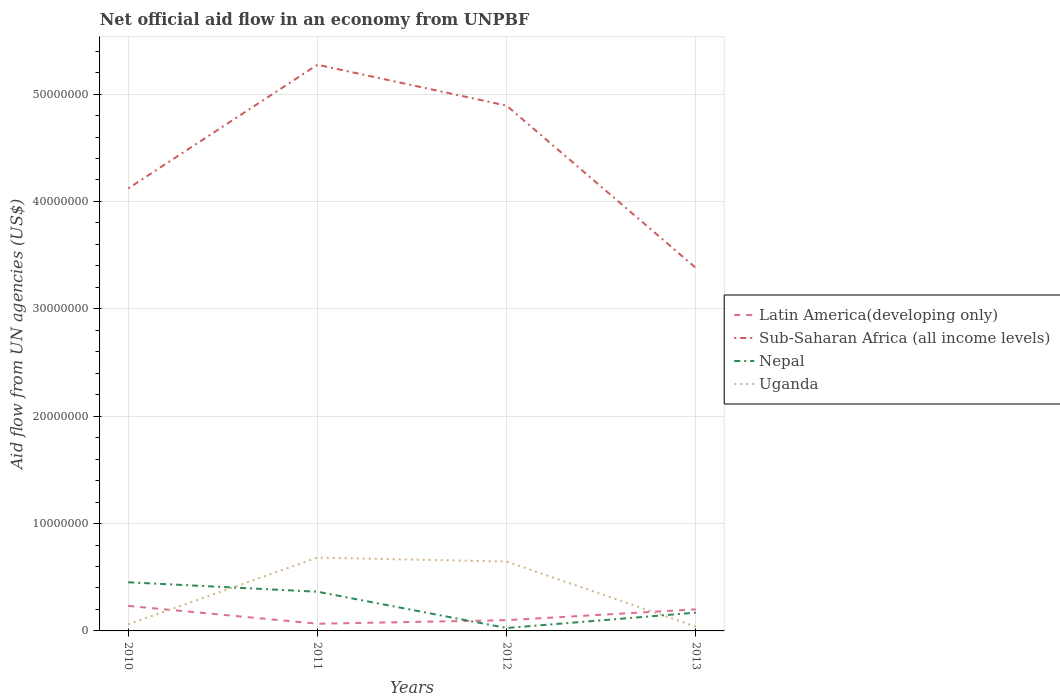How many different coloured lines are there?
Provide a short and direct response. 4. Does the line corresponding to Sub-Saharan Africa (all income levels) intersect with the line corresponding to Latin America(developing only)?
Ensure brevity in your answer.  No. Is the number of lines equal to the number of legend labels?
Offer a terse response. Yes. Across all years, what is the maximum net official aid flow in Nepal?
Make the answer very short. 2.70e+05. What is the total net official aid flow in Sub-Saharan Africa (all income levels) in the graph?
Your response must be concise. 3.81e+06. What is the difference between the highest and the second highest net official aid flow in Latin America(developing only)?
Your answer should be compact. 1.66e+06. Is the net official aid flow in Sub-Saharan Africa (all income levels) strictly greater than the net official aid flow in Latin America(developing only) over the years?
Offer a very short reply. No. How many years are there in the graph?
Ensure brevity in your answer.  4. How are the legend labels stacked?
Provide a short and direct response. Vertical. What is the title of the graph?
Provide a succinct answer. Net official aid flow in an economy from UNPBF. What is the label or title of the Y-axis?
Ensure brevity in your answer.  Aid flow from UN agencies (US$). What is the Aid flow from UN agencies (US$) in Latin America(developing only) in 2010?
Offer a very short reply. 2.33e+06. What is the Aid flow from UN agencies (US$) in Sub-Saharan Africa (all income levels) in 2010?
Offer a terse response. 4.12e+07. What is the Aid flow from UN agencies (US$) in Nepal in 2010?
Your response must be concise. 4.53e+06. What is the Aid flow from UN agencies (US$) of Latin America(developing only) in 2011?
Your answer should be compact. 6.70e+05. What is the Aid flow from UN agencies (US$) in Sub-Saharan Africa (all income levels) in 2011?
Keep it short and to the point. 5.27e+07. What is the Aid flow from UN agencies (US$) of Nepal in 2011?
Offer a terse response. 3.65e+06. What is the Aid flow from UN agencies (US$) of Uganda in 2011?
Keep it short and to the point. 6.83e+06. What is the Aid flow from UN agencies (US$) in Sub-Saharan Africa (all income levels) in 2012?
Your answer should be very brief. 4.89e+07. What is the Aid flow from UN agencies (US$) in Uganda in 2012?
Offer a very short reply. 6.46e+06. What is the Aid flow from UN agencies (US$) of Latin America(developing only) in 2013?
Your answer should be compact. 2.01e+06. What is the Aid flow from UN agencies (US$) of Sub-Saharan Africa (all income levels) in 2013?
Your answer should be compact. 3.38e+07. What is the Aid flow from UN agencies (US$) in Nepal in 2013?
Ensure brevity in your answer.  1.70e+06. Across all years, what is the maximum Aid flow from UN agencies (US$) of Latin America(developing only)?
Offer a very short reply. 2.33e+06. Across all years, what is the maximum Aid flow from UN agencies (US$) of Sub-Saharan Africa (all income levels)?
Provide a short and direct response. 5.27e+07. Across all years, what is the maximum Aid flow from UN agencies (US$) in Nepal?
Ensure brevity in your answer.  4.53e+06. Across all years, what is the maximum Aid flow from UN agencies (US$) of Uganda?
Give a very brief answer. 6.83e+06. Across all years, what is the minimum Aid flow from UN agencies (US$) in Latin America(developing only)?
Offer a terse response. 6.70e+05. Across all years, what is the minimum Aid flow from UN agencies (US$) in Sub-Saharan Africa (all income levels)?
Offer a terse response. 3.38e+07. What is the total Aid flow from UN agencies (US$) in Latin America(developing only) in the graph?
Your answer should be very brief. 6.01e+06. What is the total Aid flow from UN agencies (US$) in Sub-Saharan Africa (all income levels) in the graph?
Your response must be concise. 1.77e+08. What is the total Aid flow from UN agencies (US$) in Nepal in the graph?
Your answer should be compact. 1.02e+07. What is the total Aid flow from UN agencies (US$) of Uganda in the graph?
Your answer should be very brief. 1.43e+07. What is the difference between the Aid flow from UN agencies (US$) of Latin America(developing only) in 2010 and that in 2011?
Your answer should be very brief. 1.66e+06. What is the difference between the Aid flow from UN agencies (US$) in Sub-Saharan Africa (all income levels) in 2010 and that in 2011?
Make the answer very short. -1.15e+07. What is the difference between the Aid flow from UN agencies (US$) in Nepal in 2010 and that in 2011?
Your answer should be compact. 8.80e+05. What is the difference between the Aid flow from UN agencies (US$) of Uganda in 2010 and that in 2011?
Your answer should be compact. -6.22e+06. What is the difference between the Aid flow from UN agencies (US$) of Latin America(developing only) in 2010 and that in 2012?
Ensure brevity in your answer.  1.33e+06. What is the difference between the Aid flow from UN agencies (US$) of Sub-Saharan Africa (all income levels) in 2010 and that in 2012?
Offer a terse response. -7.71e+06. What is the difference between the Aid flow from UN agencies (US$) of Nepal in 2010 and that in 2012?
Provide a short and direct response. 4.26e+06. What is the difference between the Aid flow from UN agencies (US$) of Uganda in 2010 and that in 2012?
Provide a short and direct response. -5.85e+06. What is the difference between the Aid flow from UN agencies (US$) of Latin America(developing only) in 2010 and that in 2013?
Offer a terse response. 3.20e+05. What is the difference between the Aid flow from UN agencies (US$) of Sub-Saharan Africa (all income levels) in 2010 and that in 2013?
Offer a very short reply. 7.40e+06. What is the difference between the Aid flow from UN agencies (US$) in Nepal in 2010 and that in 2013?
Give a very brief answer. 2.83e+06. What is the difference between the Aid flow from UN agencies (US$) in Latin America(developing only) in 2011 and that in 2012?
Your answer should be very brief. -3.30e+05. What is the difference between the Aid flow from UN agencies (US$) in Sub-Saharan Africa (all income levels) in 2011 and that in 2012?
Make the answer very short. 3.81e+06. What is the difference between the Aid flow from UN agencies (US$) of Nepal in 2011 and that in 2012?
Give a very brief answer. 3.38e+06. What is the difference between the Aid flow from UN agencies (US$) in Uganda in 2011 and that in 2012?
Your response must be concise. 3.70e+05. What is the difference between the Aid flow from UN agencies (US$) of Latin America(developing only) in 2011 and that in 2013?
Make the answer very short. -1.34e+06. What is the difference between the Aid flow from UN agencies (US$) of Sub-Saharan Africa (all income levels) in 2011 and that in 2013?
Your answer should be compact. 1.89e+07. What is the difference between the Aid flow from UN agencies (US$) of Nepal in 2011 and that in 2013?
Your answer should be very brief. 1.95e+06. What is the difference between the Aid flow from UN agencies (US$) of Uganda in 2011 and that in 2013?
Your response must be concise. 6.43e+06. What is the difference between the Aid flow from UN agencies (US$) in Latin America(developing only) in 2012 and that in 2013?
Offer a terse response. -1.01e+06. What is the difference between the Aid flow from UN agencies (US$) of Sub-Saharan Africa (all income levels) in 2012 and that in 2013?
Give a very brief answer. 1.51e+07. What is the difference between the Aid flow from UN agencies (US$) in Nepal in 2012 and that in 2013?
Keep it short and to the point. -1.43e+06. What is the difference between the Aid flow from UN agencies (US$) of Uganda in 2012 and that in 2013?
Ensure brevity in your answer.  6.06e+06. What is the difference between the Aid flow from UN agencies (US$) in Latin America(developing only) in 2010 and the Aid flow from UN agencies (US$) in Sub-Saharan Africa (all income levels) in 2011?
Your answer should be very brief. -5.04e+07. What is the difference between the Aid flow from UN agencies (US$) of Latin America(developing only) in 2010 and the Aid flow from UN agencies (US$) of Nepal in 2011?
Keep it short and to the point. -1.32e+06. What is the difference between the Aid flow from UN agencies (US$) in Latin America(developing only) in 2010 and the Aid flow from UN agencies (US$) in Uganda in 2011?
Ensure brevity in your answer.  -4.50e+06. What is the difference between the Aid flow from UN agencies (US$) of Sub-Saharan Africa (all income levels) in 2010 and the Aid flow from UN agencies (US$) of Nepal in 2011?
Provide a succinct answer. 3.76e+07. What is the difference between the Aid flow from UN agencies (US$) in Sub-Saharan Africa (all income levels) in 2010 and the Aid flow from UN agencies (US$) in Uganda in 2011?
Keep it short and to the point. 3.44e+07. What is the difference between the Aid flow from UN agencies (US$) of Nepal in 2010 and the Aid flow from UN agencies (US$) of Uganda in 2011?
Offer a terse response. -2.30e+06. What is the difference between the Aid flow from UN agencies (US$) in Latin America(developing only) in 2010 and the Aid flow from UN agencies (US$) in Sub-Saharan Africa (all income levels) in 2012?
Your answer should be compact. -4.66e+07. What is the difference between the Aid flow from UN agencies (US$) of Latin America(developing only) in 2010 and the Aid flow from UN agencies (US$) of Nepal in 2012?
Provide a short and direct response. 2.06e+06. What is the difference between the Aid flow from UN agencies (US$) in Latin America(developing only) in 2010 and the Aid flow from UN agencies (US$) in Uganda in 2012?
Make the answer very short. -4.13e+06. What is the difference between the Aid flow from UN agencies (US$) in Sub-Saharan Africa (all income levels) in 2010 and the Aid flow from UN agencies (US$) in Nepal in 2012?
Ensure brevity in your answer.  4.09e+07. What is the difference between the Aid flow from UN agencies (US$) of Sub-Saharan Africa (all income levels) in 2010 and the Aid flow from UN agencies (US$) of Uganda in 2012?
Your answer should be compact. 3.48e+07. What is the difference between the Aid flow from UN agencies (US$) in Nepal in 2010 and the Aid flow from UN agencies (US$) in Uganda in 2012?
Ensure brevity in your answer.  -1.93e+06. What is the difference between the Aid flow from UN agencies (US$) of Latin America(developing only) in 2010 and the Aid flow from UN agencies (US$) of Sub-Saharan Africa (all income levels) in 2013?
Provide a succinct answer. -3.15e+07. What is the difference between the Aid flow from UN agencies (US$) in Latin America(developing only) in 2010 and the Aid flow from UN agencies (US$) in Nepal in 2013?
Your answer should be compact. 6.30e+05. What is the difference between the Aid flow from UN agencies (US$) of Latin America(developing only) in 2010 and the Aid flow from UN agencies (US$) of Uganda in 2013?
Keep it short and to the point. 1.93e+06. What is the difference between the Aid flow from UN agencies (US$) of Sub-Saharan Africa (all income levels) in 2010 and the Aid flow from UN agencies (US$) of Nepal in 2013?
Provide a short and direct response. 3.95e+07. What is the difference between the Aid flow from UN agencies (US$) in Sub-Saharan Africa (all income levels) in 2010 and the Aid flow from UN agencies (US$) in Uganda in 2013?
Your response must be concise. 4.08e+07. What is the difference between the Aid flow from UN agencies (US$) in Nepal in 2010 and the Aid flow from UN agencies (US$) in Uganda in 2013?
Ensure brevity in your answer.  4.13e+06. What is the difference between the Aid flow from UN agencies (US$) in Latin America(developing only) in 2011 and the Aid flow from UN agencies (US$) in Sub-Saharan Africa (all income levels) in 2012?
Offer a terse response. -4.82e+07. What is the difference between the Aid flow from UN agencies (US$) in Latin America(developing only) in 2011 and the Aid flow from UN agencies (US$) in Uganda in 2012?
Your response must be concise. -5.79e+06. What is the difference between the Aid flow from UN agencies (US$) of Sub-Saharan Africa (all income levels) in 2011 and the Aid flow from UN agencies (US$) of Nepal in 2012?
Offer a terse response. 5.25e+07. What is the difference between the Aid flow from UN agencies (US$) of Sub-Saharan Africa (all income levels) in 2011 and the Aid flow from UN agencies (US$) of Uganda in 2012?
Provide a short and direct response. 4.63e+07. What is the difference between the Aid flow from UN agencies (US$) of Nepal in 2011 and the Aid flow from UN agencies (US$) of Uganda in 2012?
Offer a very short reply. -2.81e+06. What is the difference between the Aid flow from UN agencies (US$) of Latin America(developing only) in 2011 and the Aid flow from UN agencies (US$) of Sub-Saharan Africa (all income levels) in 2013?
Give a very brief answer. -3.31e+07. What is the difference between the Aid flow from UN agencies (US$) of Latin America(developing only) in 2011 and the Aid flow from UN agencies (US$) of Nepal in 2013?
Provide a short and direct response. -1.03e+06. What is the difference between the Aid flow from UN agencies (US$) of Sub-Saharan Africa (all income levels) in 2011 and the Aid flow from UN agencies (US$) of Nepal in 2013?
Your answer should be very brief. 5.10e+07. What is the difference between the Aid flow from UN agencies (US$) in Sub-Saharan Africa (all income levels) in 2011 and the Aid flow from UN agencies (US$) in Uganda in 2013?
Keep it short and to the point. 5.23e+07. What is the difference between the Aid flow from UN agencies (US$) in Nepal in 2011 and the Aid flow from UN agencies (US$) in Uganda in 2013?
Offer a terse response. 3.25e+06. What is the difference between the Aid flow from UN agencies (US$) of Latin America(developing only) in 2012 and the Aid flow from UN agencies (US$) of Sub-Saharan Africa (all income levels) in 2013?
Your response must be concise. -3.28e+07. What is the difference between the Aid flow from UN agencies (US$) in Latin America(developing only) in 2012 and the Aid flow from UN agencies (US$) in Nepal in 2013?
Give a very brief answer. -7.00e+05. What is the difference between the Aid flow from UN agencies (US$) in Latin America(developing only) in 2012 and the Aid flow from UN agencies (US$) in Uganda in 2013?
Offer a very short reply. 6.00e+05. What is the difference between the Aid flow from UN agencies (US$) in Sub-Saharan Africa (all income levels) in 2012 and the Aid flow from UN agencies (US$) in Nepal in 2013?
Ensure brevity in your answer.  4.72e+07. What is the difference between the Aid flow from UN agencies (US$) in Sub-Saharan Africa (all income levels) in 2012 and the Aid flow from UN agencies (US$) in Uganda in 2013?
Provide a short and direct response. 4.85e+07. What is the difference between the Aid flow from UN agencies (US$) of Nepal in 2012 and the Aid flow from UN agencies (US$) of Uganda in 2013?
Your answer should be compact. -1.30e+05. What is the average Aid flow from UN agencies (US$) in Latin America(developing only) per year?
Keep it short and to the point. 1.50e+06. What is the average Aid flow from UN agencies (US$) of Sub-Saharan Africa (all income levels) per year?
Provide a succinct answer. 4.42e+07. What is the average Aid flow from UN agencies (US$) in Nepal per year?
Ensure brevity in your answer.  2.54e+06. What is the average Aid flow from UN agencies (US$) of Uganda per year?
Provide a short and direct response. 3.58e+06. In the year 2010, what is the difference between the Aid flow from UN agencies (US$) of Latin America(developing only) and Aid flow from UN agencies (US$) of Sub-Saharan Africa (all income levels)?
Make the answer very short. -3.89e+07. In the year 2010, what is the difference between the Aid flow from UN agencies (US$) of Latin America(developing only) and Aid flow from UN agencies (US$) of Nepal?
Make the answer very short. -2.20e+06. In the year 2010, what is the difference between the Aid flow from UN agencies (US$) in Latin America(developing only) and Aid flow from UN agencies (US$) in Uganda?
Provide a short and direct response. 1.72e+06. In the year 2010, what is the difference between the Aid flow from UN agencies (US$) in Sub-Saharan Africa (all income levels) and Aid flow from UN agencies (US$) in Nepal?
Provide a short and direct response. 3.67e+07. In the year 2010, what is the difference between the Aid flow from UN agencies (US$) in Sub-Saharan Africa (all income levels) and Aid flow from UN agencies (US$) in Uganda?
Offer a terse response. 4.06e+07. In the year 2010, what is the difference between the Aid flow from UN agencies (US$) of Nepal and Aid flow from UN agencies (US$) of Uganda?
Your answer should be compact. 3.92e+06. In the year 2011, what is the difference between the Aid flow from UN agencies (US$) in Latin America(developing only) and Aid flow from UN agencies (US$) in Sub-Saharan Africa (all income levels)?
Make the answer very short. -5.21e+07. In the year 2011, what is the difference between the Aid flow from UN agencies (US$) in Latin America(developing only) and Aid flow from UN agencies (US$) in Nepal?
Your answer should be very brief. -2.98e+06. In the year 2011, what is the difference between the Aid flow from UN agencies (US$) in Latin America(developing only) and Aid flow from UN agencies (US$) in Uganda?
Provide a short and direct response. -6.16e+06. In the year 2011, what is the difference between the Aid flow from UN agencies (US$) of Sub-Saharan Africa (all income levels) and Aid flow from UN agencies (US$) of Nepal?
Give a very brief answer. 4.91e+07. In the year 2011, what is the difference between the Aid flow from UN agencies (US$) of Sub-Saharan Africa (all income levels) and Aid flow from UN agencies (US$) of Uganda?
Give a very brief answer. 4.59e+07. In the year 2011, what is the difference between the Aid flow from UN agencies (US$) in Nepal and Aid flow from UN agencies (US$) in Uganda?
Provide a short and direct response. -3.18e+06. In the year 2012, what is the difference between the Aid flow from UN agencies (US$) of Latin America(developing only) and Aid flow from UN agencies (US$) of Sub-Saharan Africa (all income levels)?
Provide a succinct answer. -4.79e+07. In the year 2012, what is the difference between the Aid flow from UN agencies (US$) of Latin America(developing only) and Aid flow from UN agencies (US$) of Nepal?
Your answer should be compact. 7.30e+05. In the year 2012, what is the difference between the Aid flow from UN agencies (US$) in Latin America(developing only) and Aid flow from UN agencies (US$) in Uganda?
Your answer should be compact. -5.46e+06. In the year 2012, what is the difference between the Aid flow from UN agencies (US$) of Sub-Saharan Africa (all income levels) and Aid flow from UN agencies (US$) of Nepal?
Your answer should be compact. 4.86e+07. In the year 2012, what is the difference between the Aid flow from UN agencies (US$) in Sub-Saharan Africa (all income levels) and Aid flow from UN agencies (US$) in Uganda?
Your answer should be very brief. 4.25e+07. In the year 2012, what is the difference between the Aid flow from UN agencies (US$) of Nepal and Aid flow from UN agencies (US$) of Uganda?
Keep it short and to the point. -6.19e+06. In the year 2013, what is the difference between the Aid flow from UN agencies (US$) in Latin America(developing only) and Aid flow from UN agencies (US$) in Sub-Saharan Africa (all income levels)?
Your response must be concise. -3.18e+07. In the year 2013, what is the difference between the Aid flow from UN agencies (US$) in Latin America(developing only) and Aid flow from UN agencies (US$) in Nepal?
Keep it short and to the point. 3.10e+05. In the year 2013, what is the difference between the Aid flow from UN agencies (US$) of Latin America(developing only) and Aid flow from UN agencies (US$) of Uganda?
Offer a terse response. 1.61e+06. In the year 2013, what is the difference between the Aid flow from UN agencies (US$) in Sub-Saharan Africa (all income levels) and Aid flow from UN agencies (US$) in Nepal?
Offer a terse response. 3.21e+07. In the year 2013, what is the difference between the Aid flow from UN agencies (US$) of Sub-Saharan Africa (all income levels) and Aid flow from UN agencies (US$) of Uganda?
Ensure brevity in your answer.  3.34e+07. In the year 2013, what is the difference between the Aid flow from UN agencies (US$) in Nepal and Aid flow from UN agencies (US$) in Uganda?
Your answer should be very brief. 1.30e+06. What is the ratio of the Aid flow from UN agencies (US$) in Latin America(developing only) in 2010 to that in 2011?
Provide a short and direct response. 3.48. What is the ratio of the Aid flow from UN agencies (US$) in Sub-Saharan Africa (all income levels) in 2010 to that in 2011?
Offer a very short reply. 0.78. What is the ratio of the Aid flow from UN agencies (US$) in Nepal in 2010 to that in 2011?
Your answer should be compact. 1.24. What is the ratio of the Aid flow from UN agencies (US$) of Uganda in 2010 to that in 2011?
Make the answer very short. 0.09. What is the ratio of the Aid flow from UN agencies (US$) in Latin America(developing only) in 2010 to that in 2012?
Offer a terse response. 2.33. What is the ratio of the Aid flow from UN agencies (US$) of Sub-Saharan Africa (all income levels) in 2010 to that in 2012?
Offer a very short reply. 0.84. What is the ratio of the Aid flow from UN agencies (US$) of Nepal in 2010 to that in 2012?
Make the answer very short. 16.78. What is the ratio of the Aid flow from UN agencies (US$) of Uganda in 2010 to that in 2012?
Provide a succinct answer. 0.09. What is the ratio of the Aid flow from UN agencies (US$) in Latin America(developing only) in 2010 to that in 2013?
Give a very brief answer. 1.16. What is the ratio of the Aid flow from UN agencies (US$) of Sub-Saharan Africa (all income levels) in 2010 to that in 2013?
Your answer should be very brief. 1.22. What is the ratio of the Aid flow from UN agencies (US$) in Nepal in 2010 to that in 2013?
Keep it short and to the point. 2.66. What is the ratio of the Aid flow from UN agencies (US$) in Uganda in 2010 to that in 2013?
Your response must be concise. 1.52. What is the ratio of the Aid flow from UN agencies (US$) of Latin America(developing only) in 2011 to that in 2012?
Your answer should be very brief. 0.67. What is the ratio of the Aid flow from UN agencies (US$) in Sub-Saharan Africa (all income levels) in 2011 to that in 2012?
Ensure brevity in your answer.  1.08. What is the ratio of the Aid flow from UN agencies (US$) in Nepal in 2011 to that in 2012?
Make the answer very short. 13.52. What is the ratio of the Aid flow from UN agencies (US$) of Uganda in 2011 to that in 2012?
Your answer should be compact. 1.06. What is the ratio of the Aid flow from UN agencies (US$) of Sub-Saharan Africa (all income levels) in 2011 to that in 2013?
Your answer should be compact. 1.56. What is the ratio of the Aid flow from UN agencies (US$) in Nepal in 2011 to that in 2013?
Your answer should be very brief. 2.15. What is the ratio of the Aid flow from UN agencies (US$) in Uganda in 2011 to that in 2013?
Your answer should be very brief. 17.07. What is the ratio of the Aid flow from UN agencies (US$) in Latin America(developing only) in 2012 to that in 2013?
Offer a very short reply. 0.5. What is the ratio of the Aid flow from UN agencies (US$) of Sub-Saharan Africa (all income levels) in 2012 to that in 2013?
Ensure brevity in your answer.  1.45. What is the ratio of the Aid flow from UN agencies (US$) in Nepal in 2012 to that in 2013?
Offer a very short reply. 0.16. What is the ratio of the Aid flow from UN agencies (US$) in Uganda in 2012 to that in 2013?
Offer a very short reply. 16.15. What is the difference between the highest and the second highest Aid flow from UN agencies (US$) in Sub-Saharan Africa (all income levels)?
Ensure brevity in your answer.  3.81e+06. What is the difference between the highest and the second highest Aid flow from UN agencies (US$) of Nepal?
Give a very brief answer. 8.80e+05. What is the difference between the highest and the second highest Aid flow from UN agencies (US$) of Uganda?
Your answer should be very brief. 3.70e+05. What is the difference between the highest and the lowest Aid flow from UN agencies (US$) of Latin America(developing only)?
Your answer should be compact. 1.66e+06. What is the difference between the highest and the lowest Aid flow from UN agencies (US$) of Sub-Saharan Africa (all income levels)?
Your answer should be very brief. 1.89e+07. What is the difference between the highest and the lowest Aid flow from UN agencies (US$) of Nepal?
Offer a terse response. 4.26e+06. What is the difference between the highest and the lowest Aid flow from UN agencies (US$) in Uganda?
Your answer should be compact. 6.43e+06. 